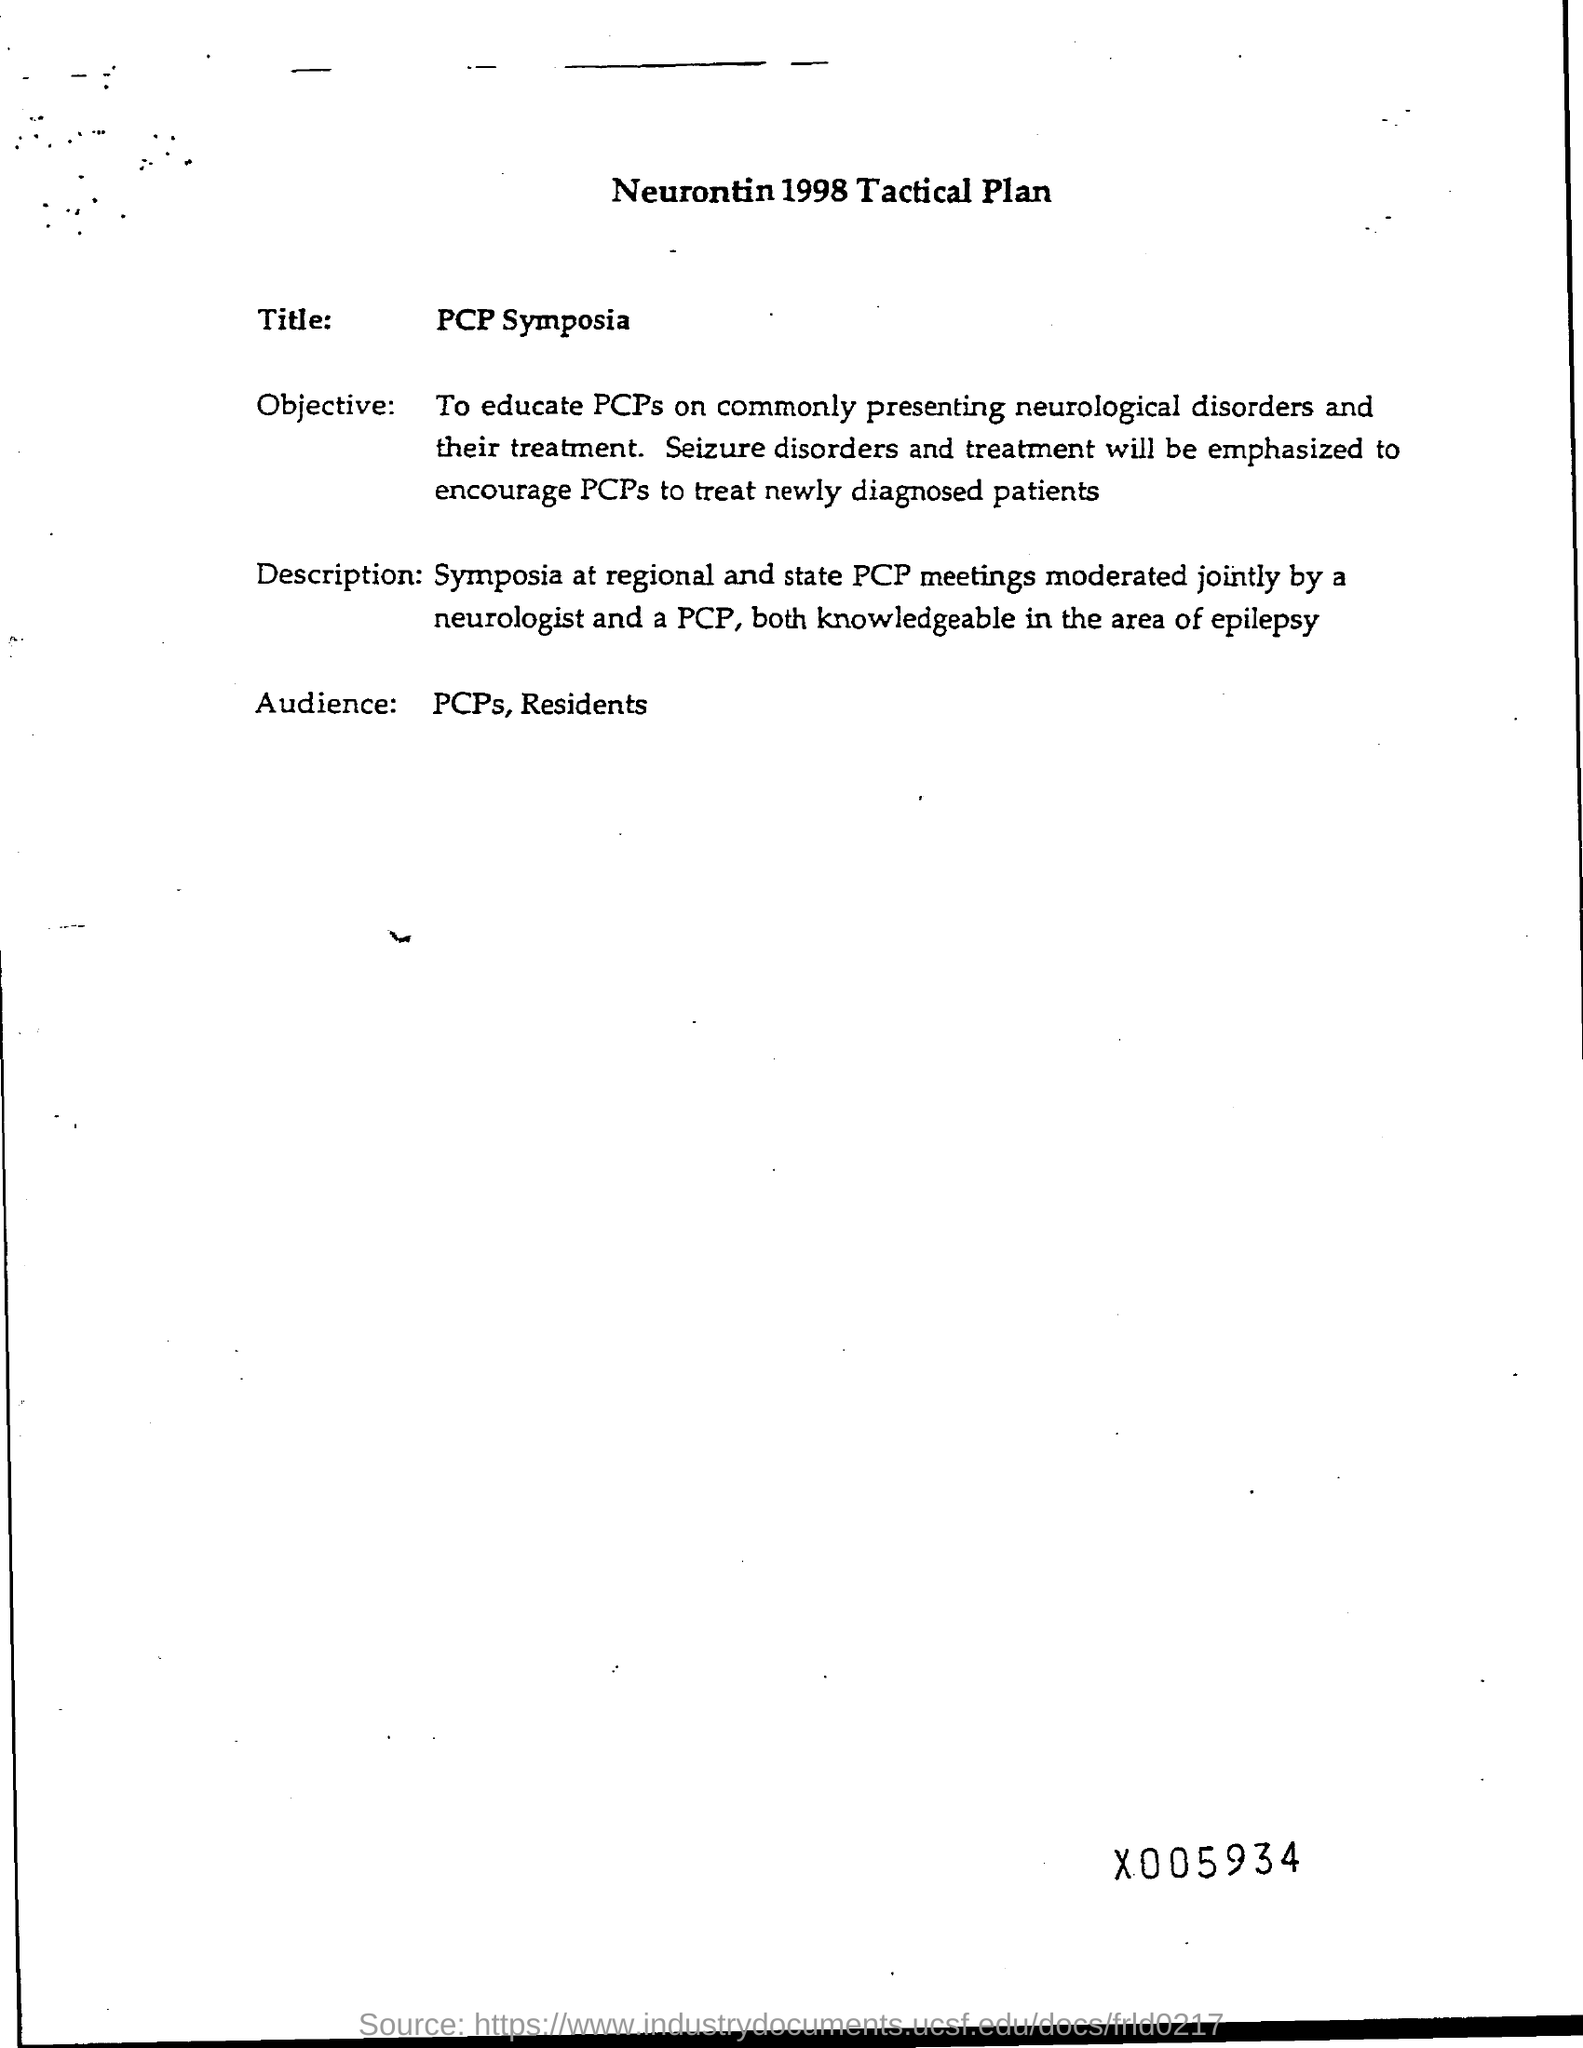What is the title ?
Offer a terse response. Pcp symposia. Who are audience ?
Offer a very short reply. PCPs, Residents. What is the title of the page ?
Make the answer very short. Neurontin 1998 tactical plan. 